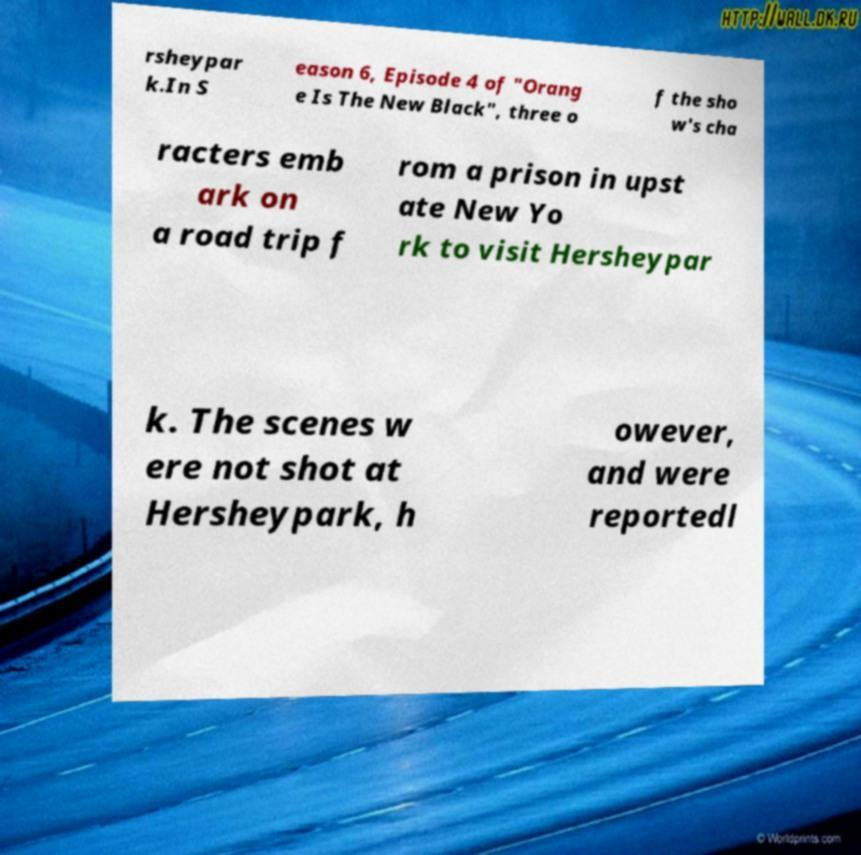Please identify and transcribe the text found in this image. rsheypar k.In S eason 6, Episode 4 of "Orang e Is The New Black", three o f the sho w's cha racters emb ark on a road trip f rom a prison in upst ate New Yo rk to visit Hersheypar k. The scenes w ere not shot at Hersheypark, h owever, and were reportedl 